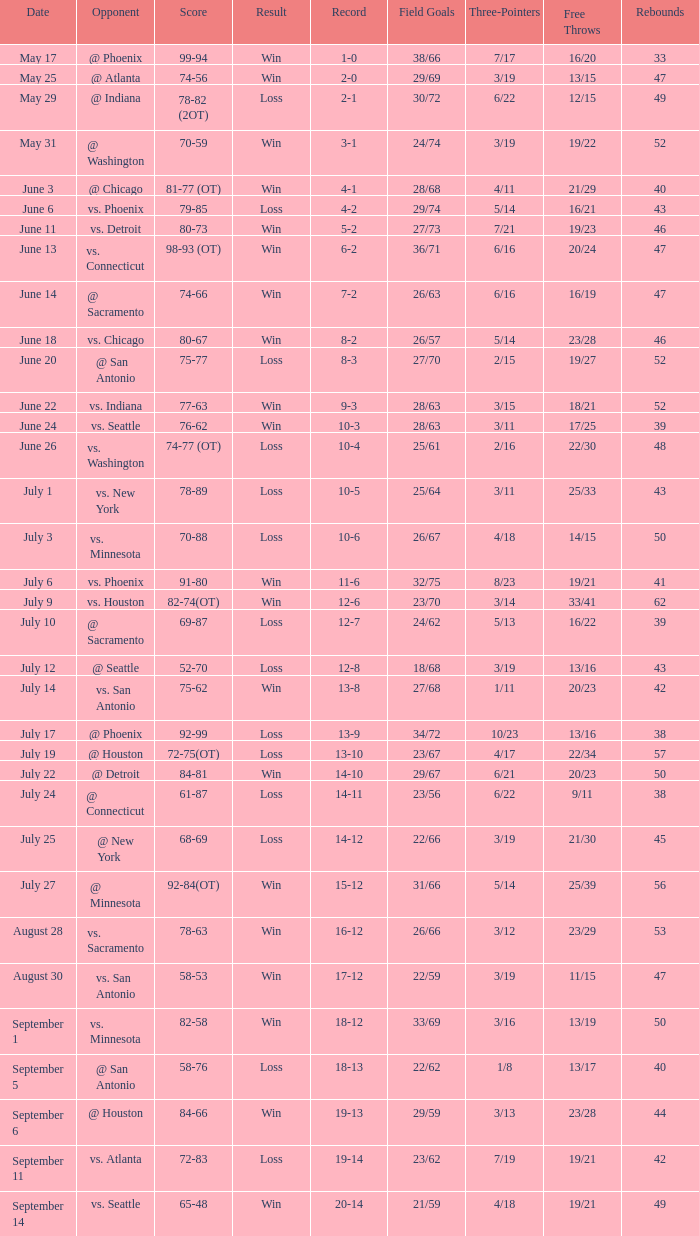What is the Opponent of the game with a Score of 74-66? @ Sacramento. 